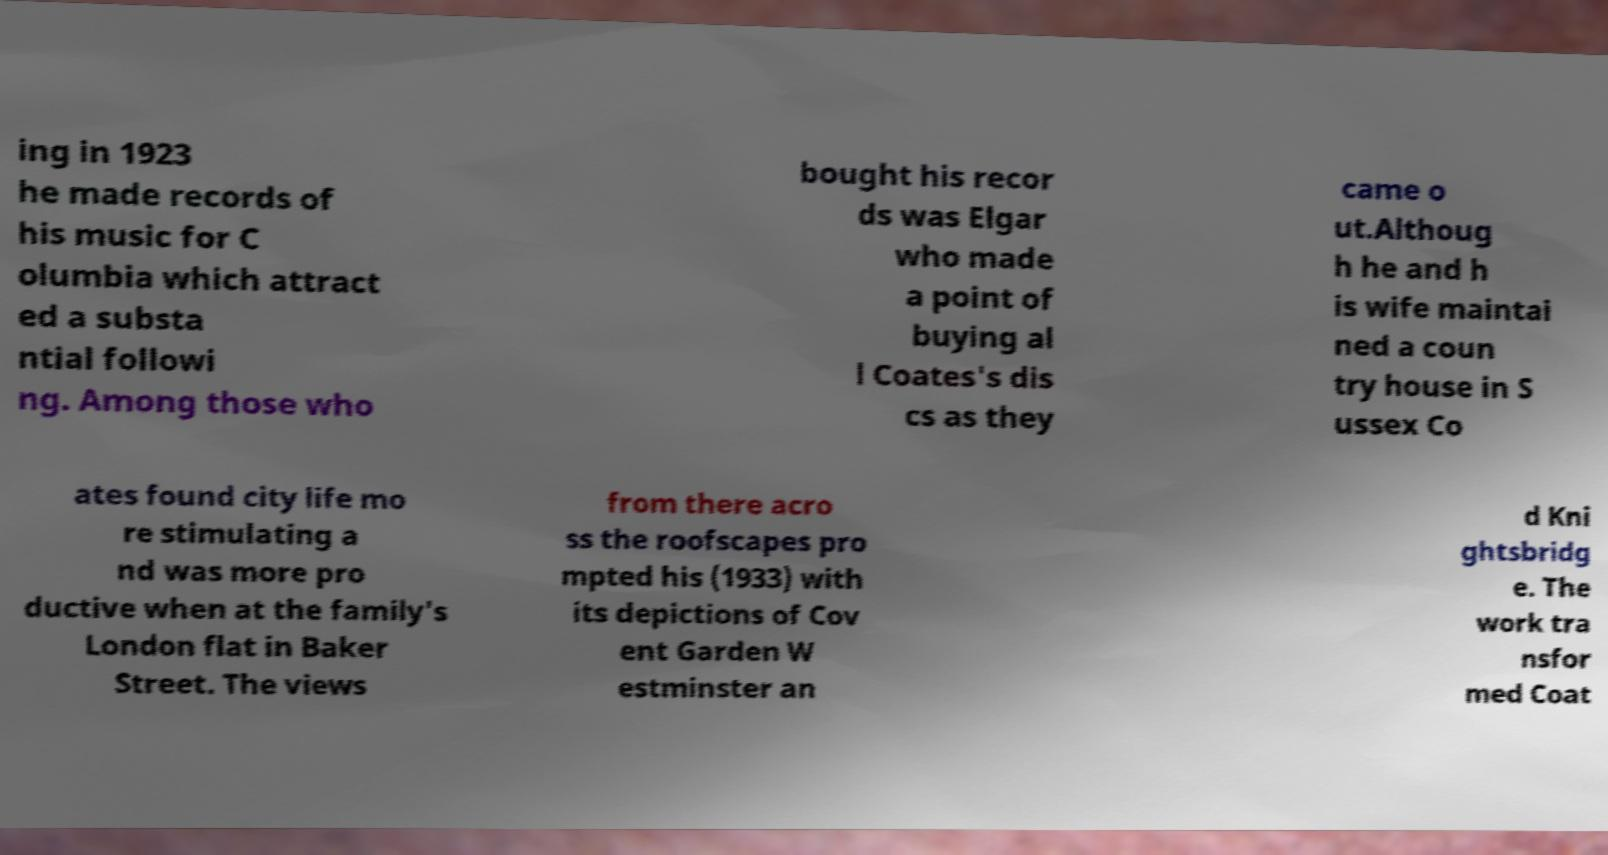Can you read and provide the text displayed in the image?This photo seems to have some interesting text. Can you extract and type it out for me? ing in 1923 he made records of his music for C olumbia which attract ed a substa ntial followi ng. Among those who bought his recor ds was Elgar who made a point of buying al l Coates's dis cs as they came o ut.Althoug h he and h is wife maintai ned a coun try house in S ussex Co ates found city life mo re stimulating a nd was more pro ductive when at the family's London flat in Baker Street. The views from there acro ss the roofscapes pro mpted his (1933) with its depictions of Cov ent Garden W estminster an d Kni ghtsbridg e. The work tra nsfor med Coat 